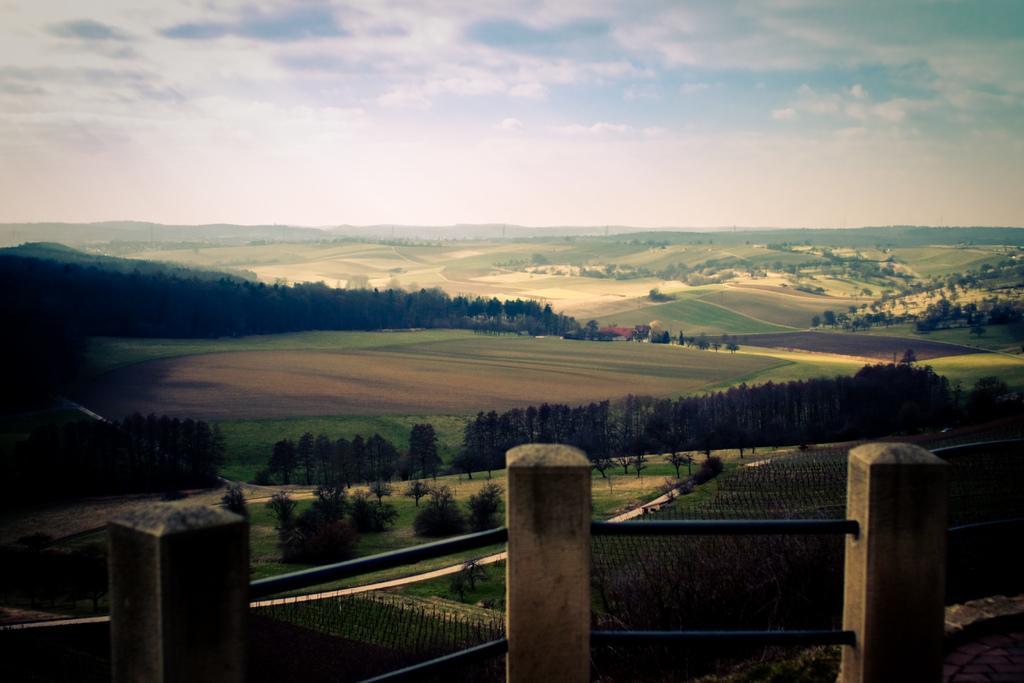How would you summarize this image in a sentence or two? There are three poles with rods attached to that. In the background there are trees, meadows and sky. 